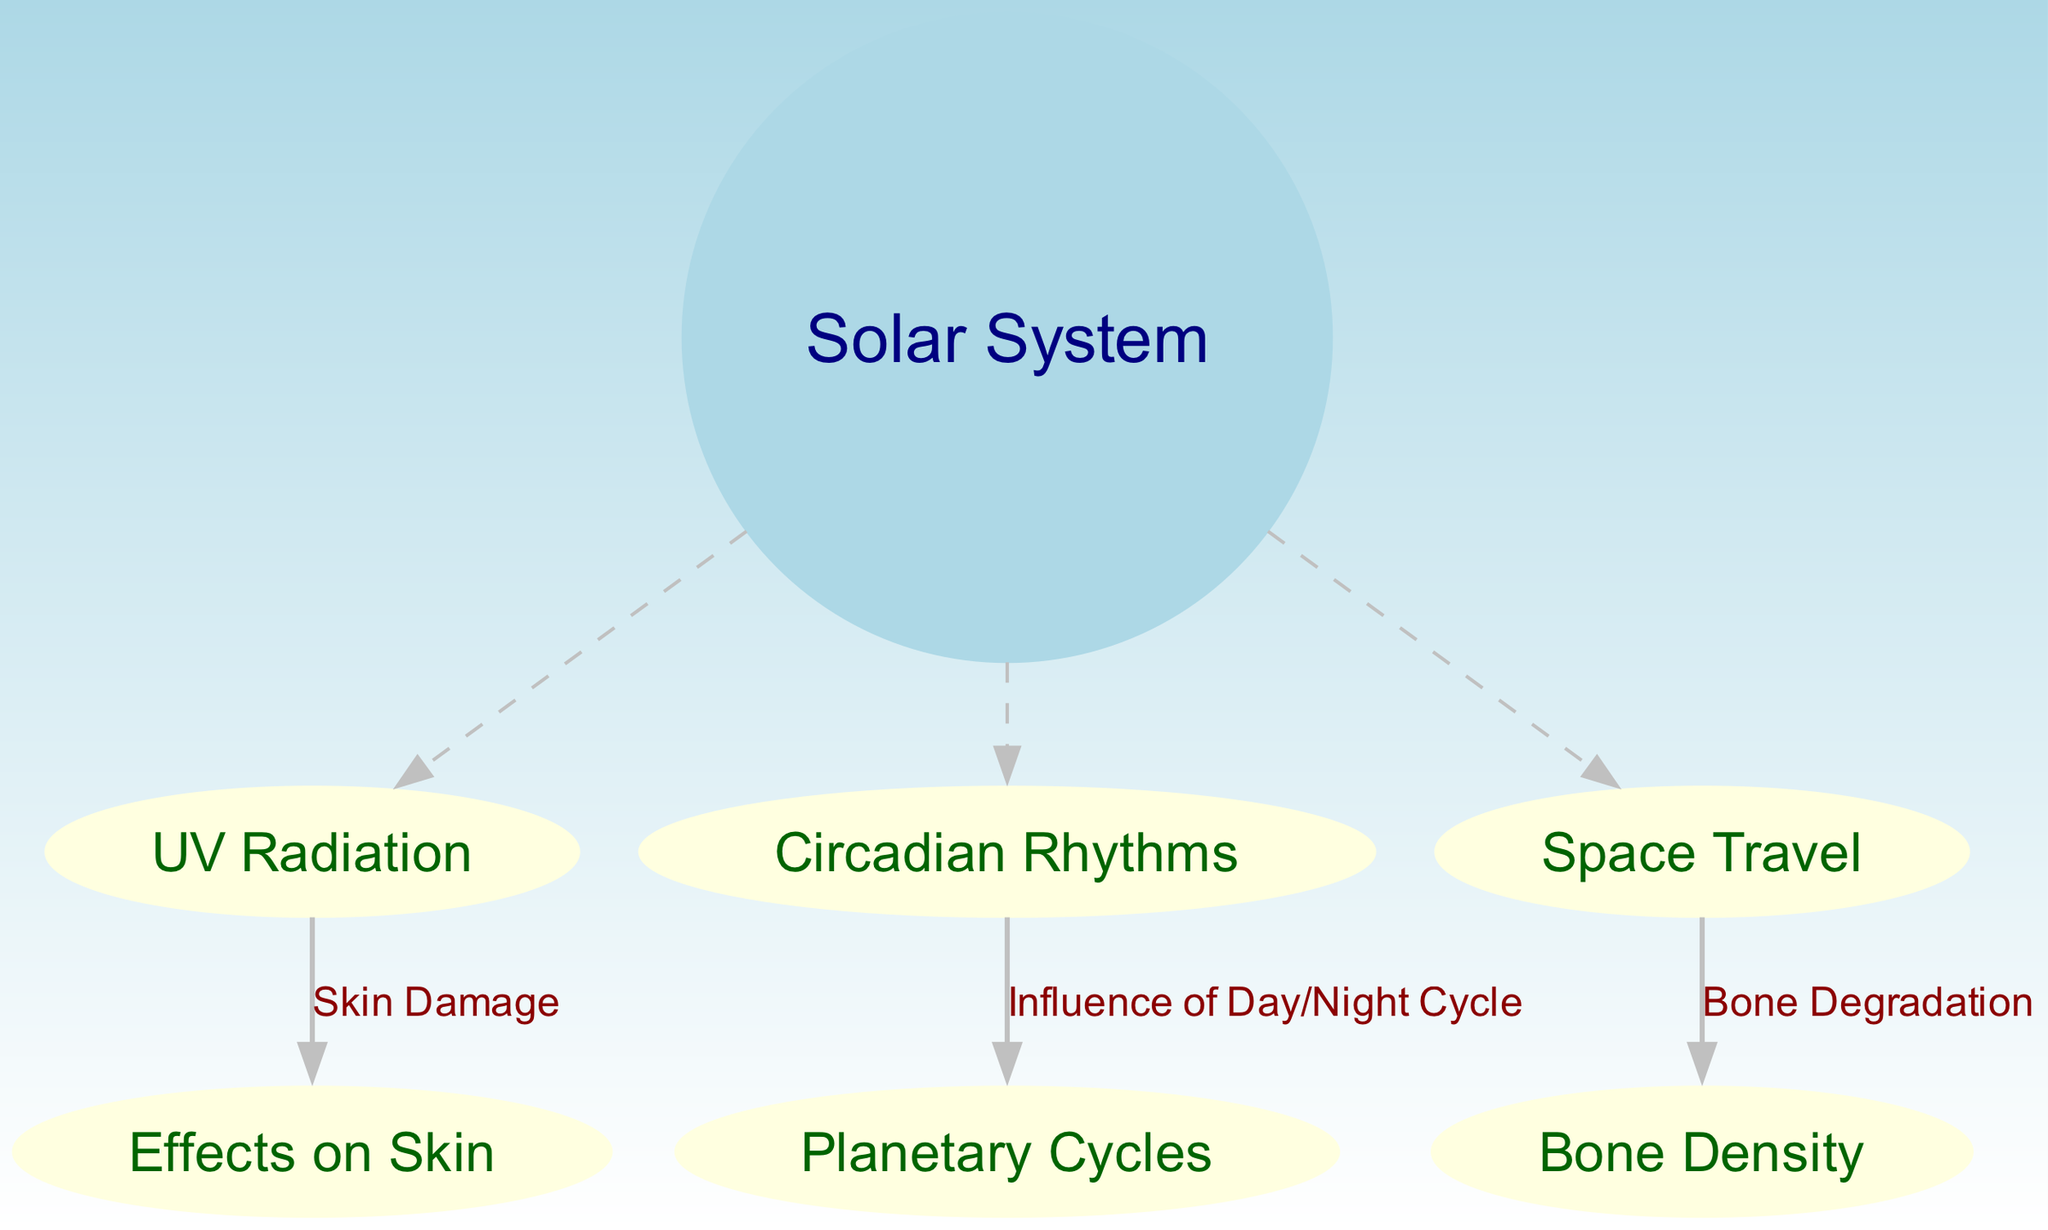What is the group depicted in the center of the diagram? The center of the diagram contains the node labeled "Solar System," which serves as the primary grouping for the related concepts of UV radiation, circadian rhythms, and space travel.
Answer: Solar System How many entities are connected to the Solar System? The diagram shows three entities directly connected to the "Solar System": "UV Radiation," "Circadian Rhythms," and "Space Travel." Counting these nodes gives us the total of three connections.
Answer: Three What is the specific effect of UV radiation on skin? From the diagram, the effect of "UV Radiation" on human health is specified as "Skin Damage," highlighting the direct relationship between UV exposure and adverse skin effects.
Answer: Skin Damage Which nodes are influenced by planetary cycles? The node "Circadian Rhythms" is directly linked to "Planetary Cycles," indicating that the rhythms are affected by these cycles, such as the day/night cycle caused by planetary movements.
Answer: Planetary Cycles What condition is associated with space travel according to the diagram? The diagram shows a connection from "Space Travel" to "Bone Density," indicating that bone density issues are a consequence of the conditions encountered during space travel, such as reduced gravity.
Answer: Bone Degradation How does circadian rhythm relate to the solar system? The "Circadian Rhythms" node is connected to the "Solar System," illustrating that these rhythms are influenced by solar phenomena, particularly the cycles of day and night determined by the Earth's rotation and orbit around the Sun.
Answer: Influence of Day/Night Cycle Which node represents a potential health issue due to UV radiation? The node labeled "Effects on Skin" directly follows from "UV Radiation," indicating that it is the health issue stemming from exposure to UV rays, emphasizing potential skin problems associated with UV light.
Answer: Effects on Skin What type of health degradation is linked to space travel? The diagram specifies "Bone Degradation" as the condition linked to "Space Travel," outlining how astronauts may experience lower bone density due to the effects of prolonged weightlessness.
Answer: Bone Degradation 